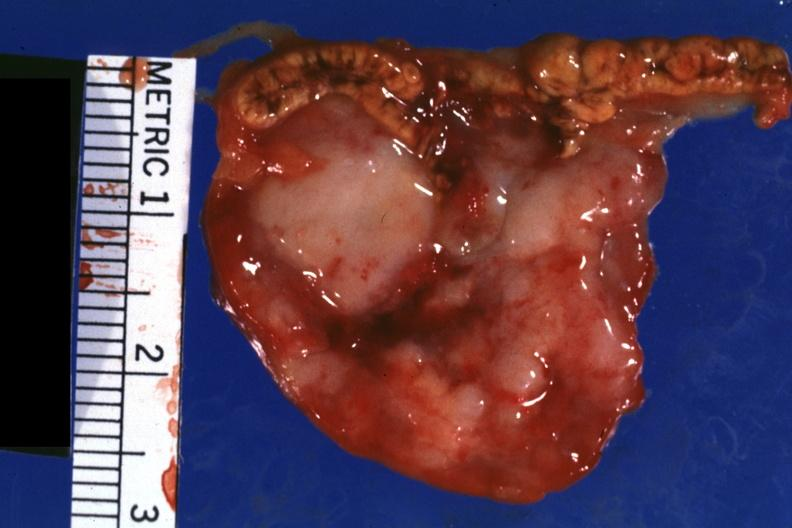what is present?
Answer the question using a single word or phrase. Adrenal 